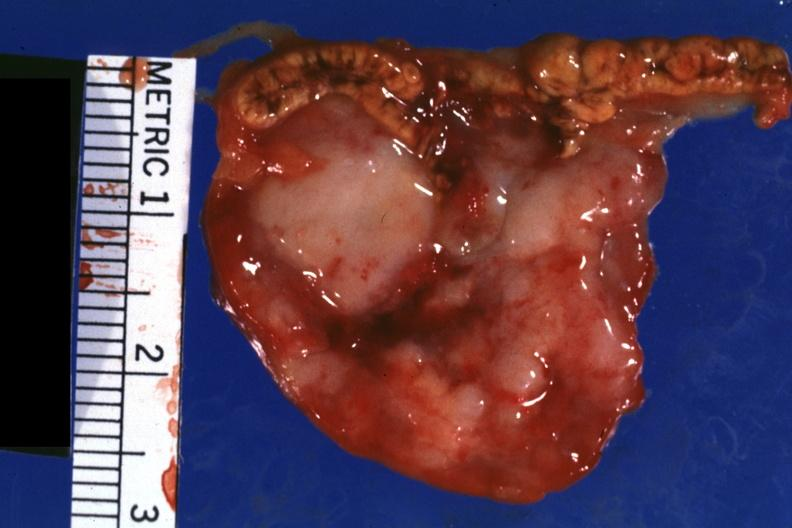what is present?
Answer the question using a single word or phrase. Adrenal 